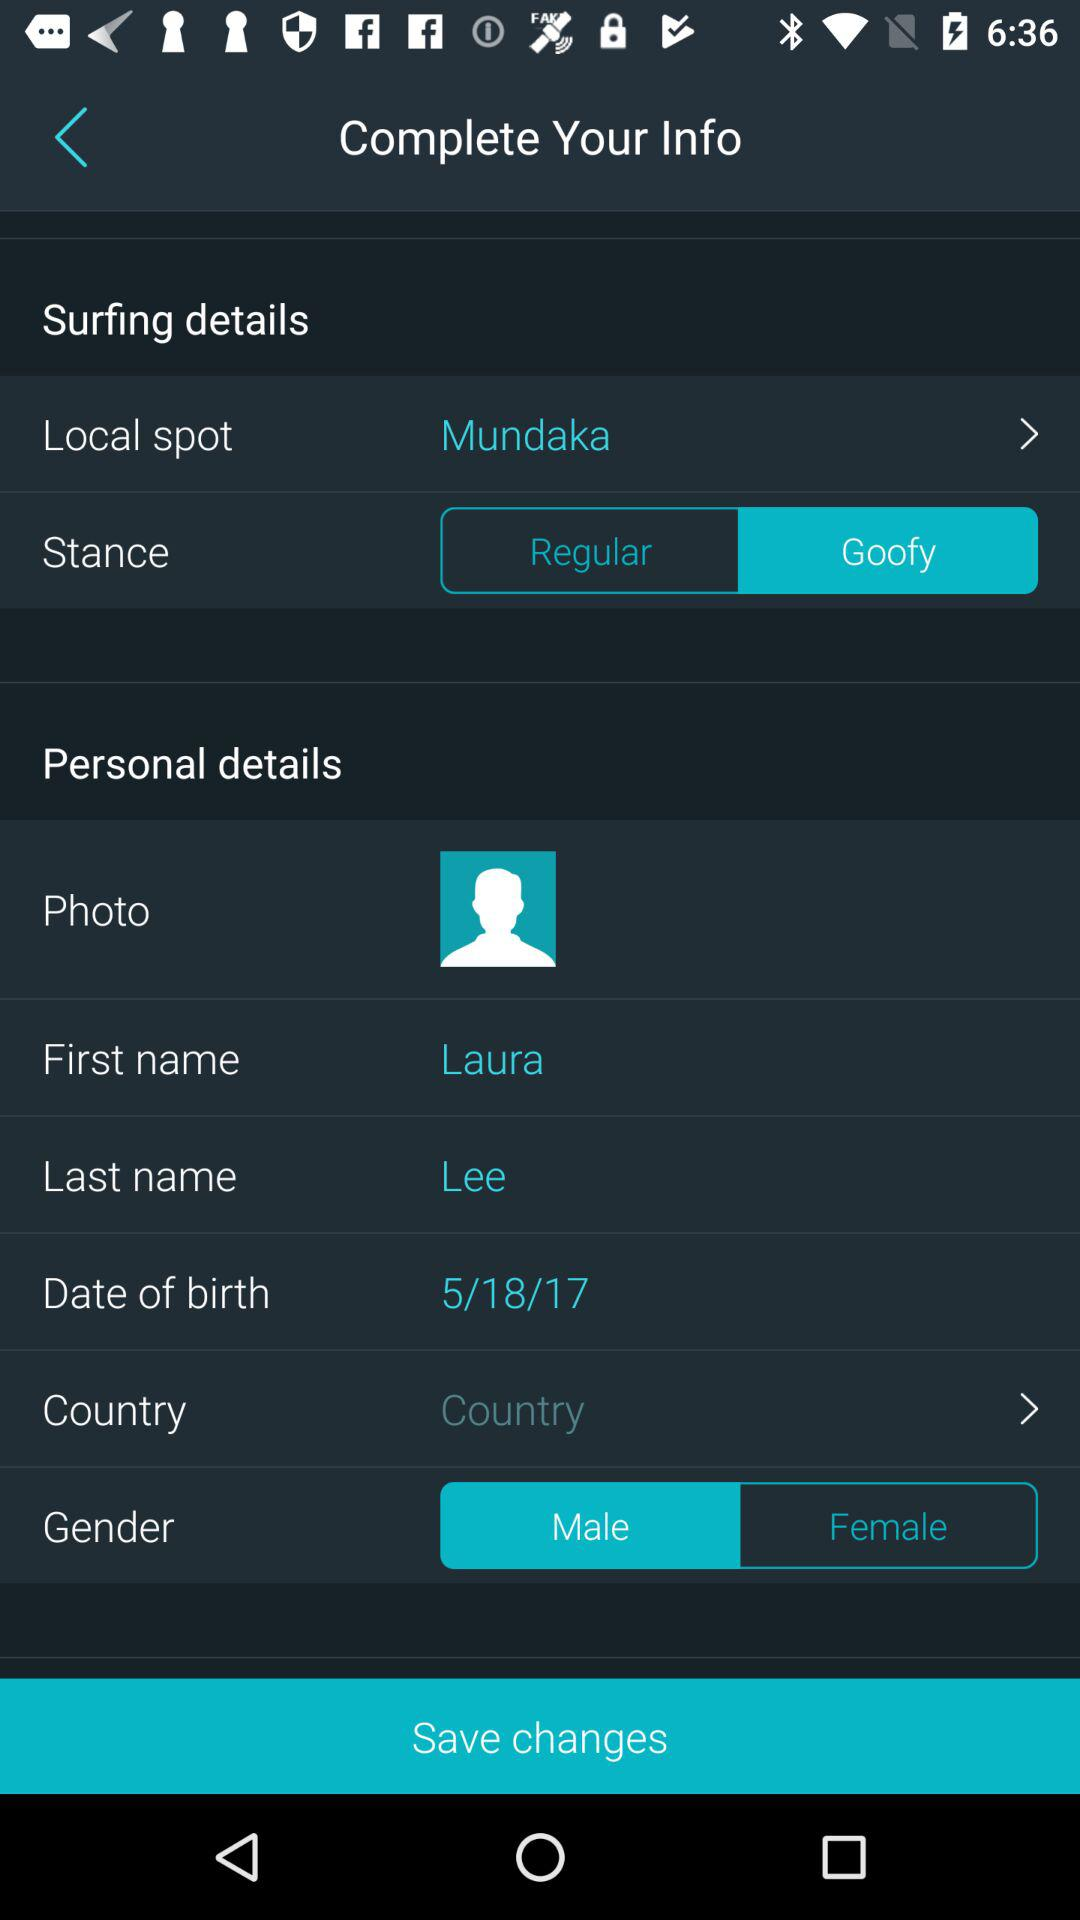What is the date of birth? The date of birth is 5/18/17. 